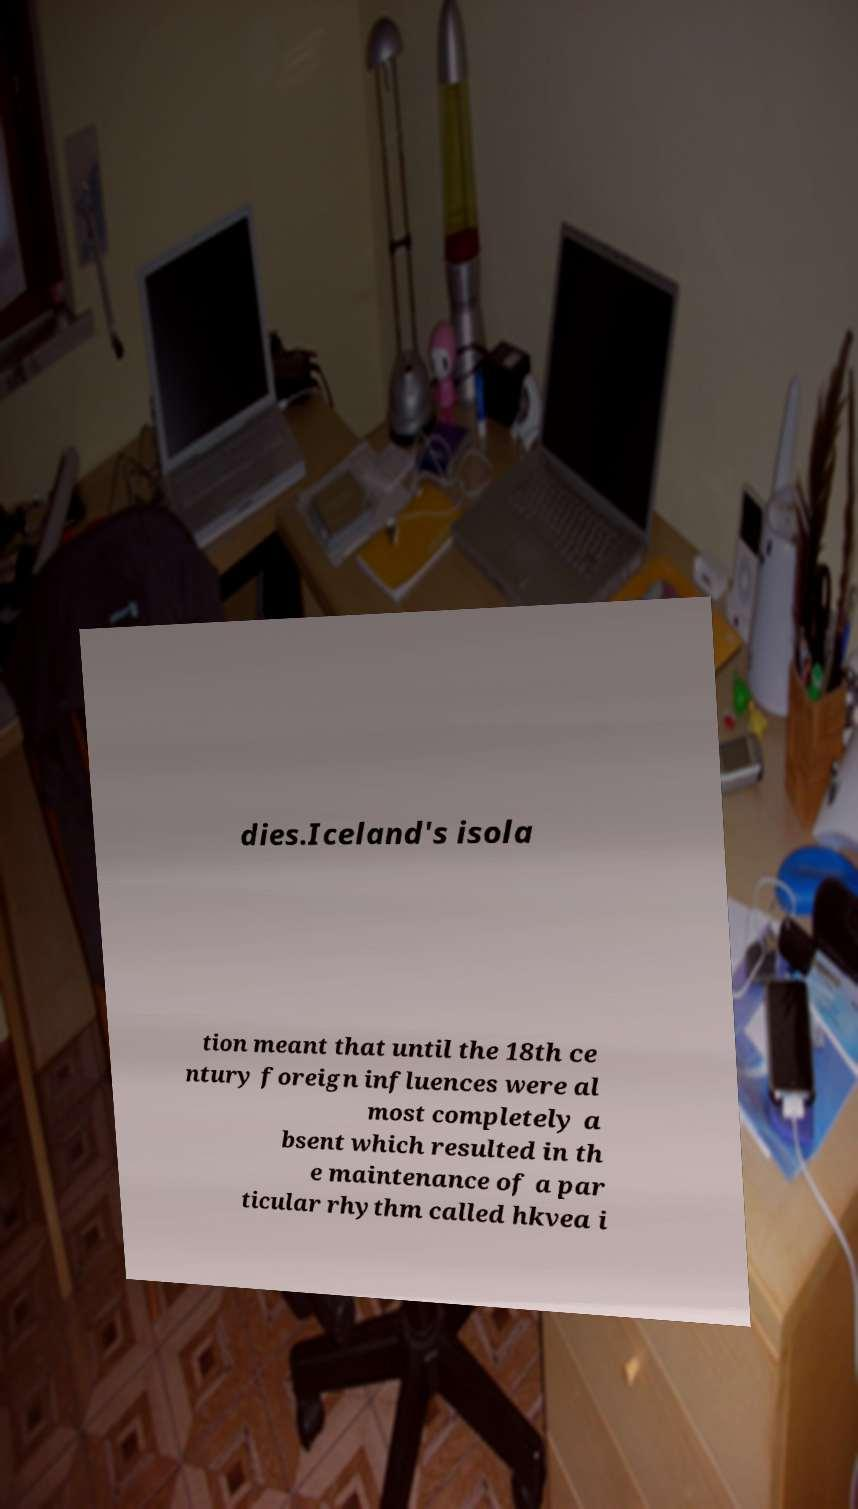Please identify and transcribe the text found in this image. dies.Iceland's isola tion meant that until the 18th ce ntury foreign influences were al most completely a bsent which resulted in th e maintenance of a par ticular rhythm called hkvea i 